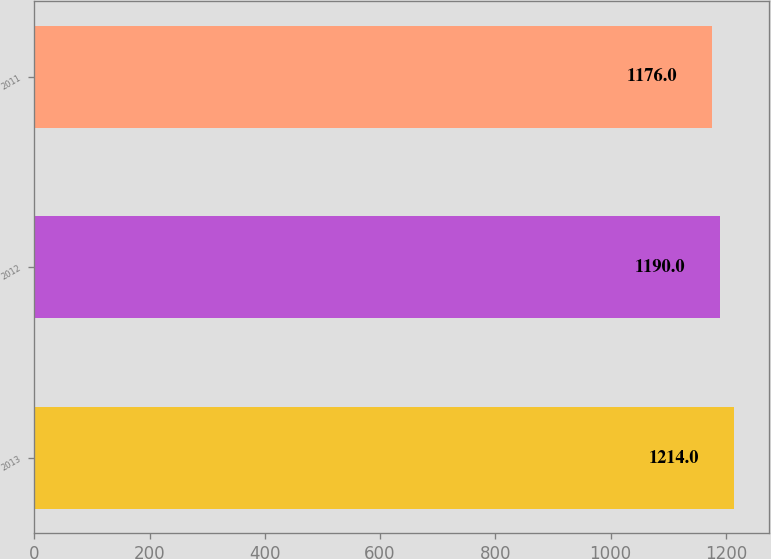Convert chart. <chart><loc_0><loc_0><loc_500><loc_500><bar_chart><fcel>2013<fcel>2012<fcel>2011<nl><fcel>1214<fcel>1190<fcel>1176<nl></chart> 